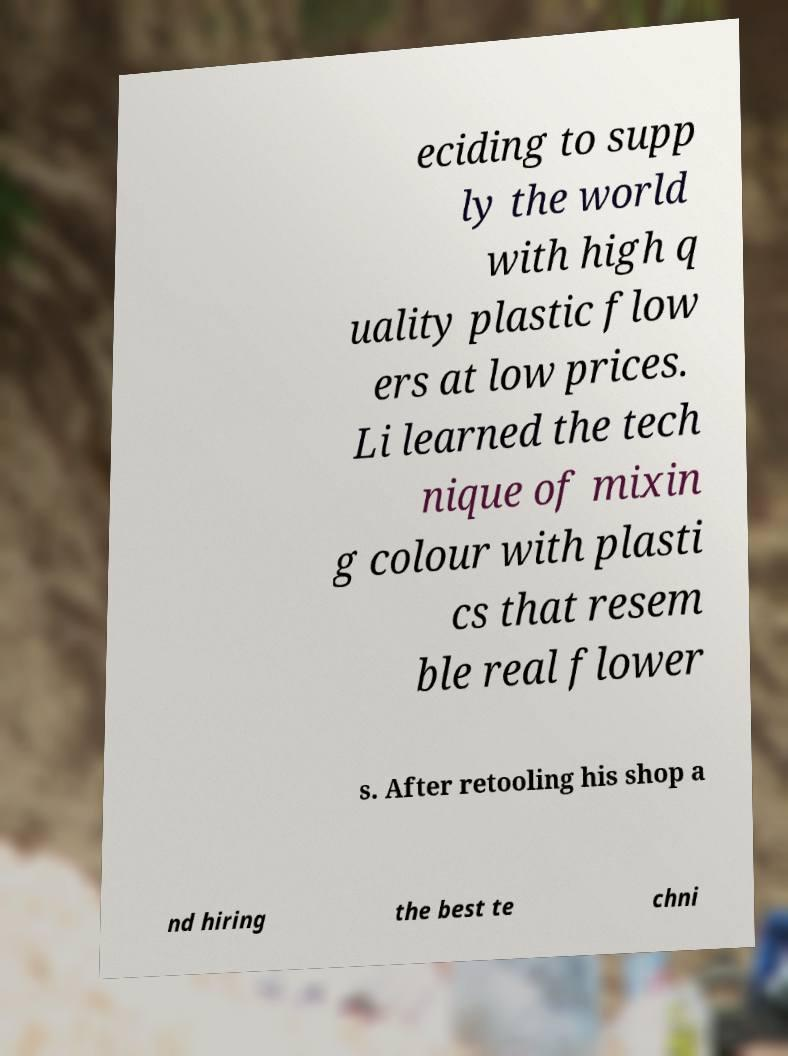There's text embedded in this image that I need extracted. Can you transcribe it verbatim? eciding to supp ly the world with high q uality plastic flow ers at low prices. Li learned the tech nique of mixin g colour with plasti cs that resem ble real flower s. After retooling his shop a nd hiring the best te chni 